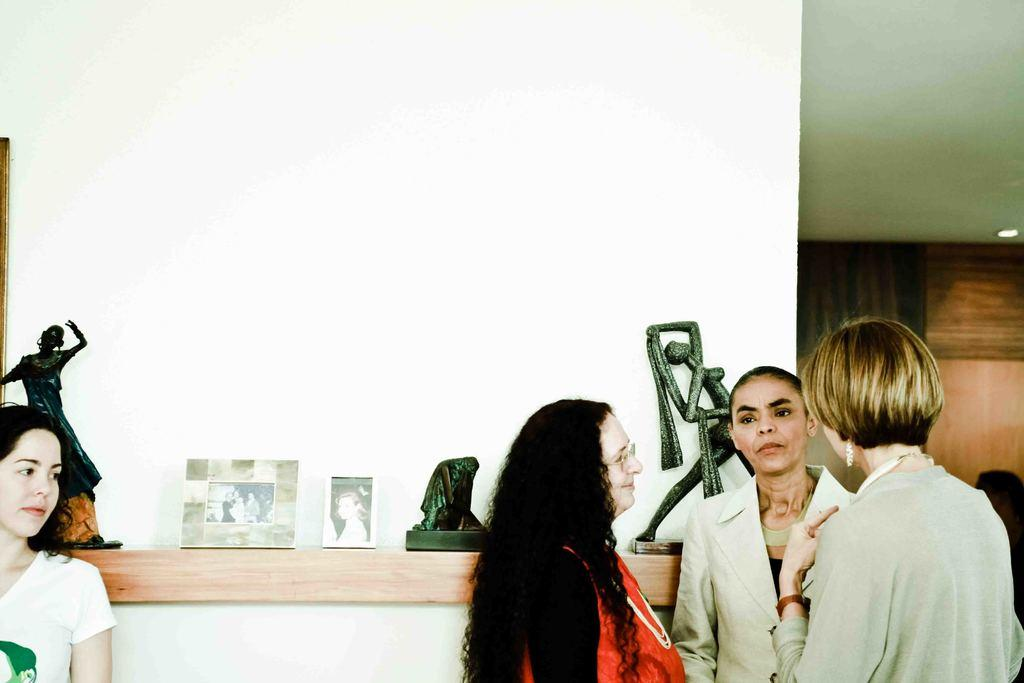What are the people in the image wearing? The persons in the image are wearing clothes. What type of artwork can be seen in the image? There are sculptures in the image. What else can be seen on the wall shelf besides sculptures? There are photo frames on the wall shelf. What part of the room is visible in the top right of the image? The ceiling is visible in the top right of the image. What type of lipstick is the person wearing in the image? There is no lipstick or indication of lipstick in the image. What date is marked on the calendar in the image? There is no calendar present in the image. 